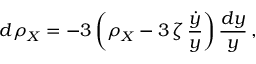<formula> <loc_0><loc_0><loc_500><loc_500>d \rho _ { X } = - 3 \left ( \rho _ { X } - 3 \, \zeta \, \frac { \dot { y } } { y } \right ) \frac { d y } { y } \, ,</formula> 